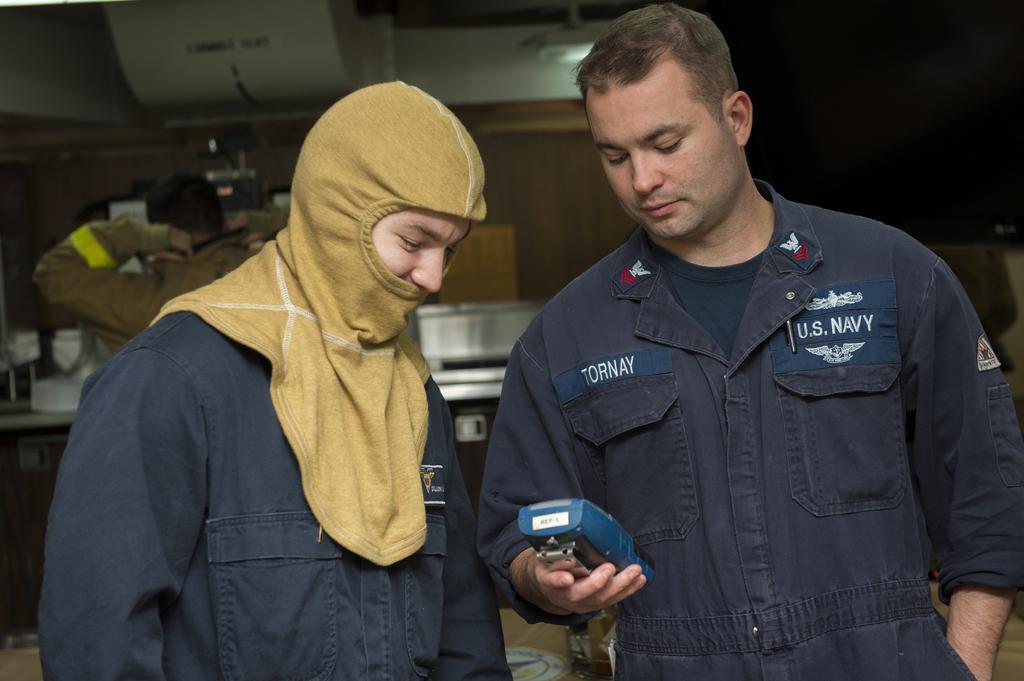Could you give a brief overview of what you see in this image? In this image in the front there are persons standing. On the right side there is a man standing and holding an object which is blue in colour. In the background there is a person and there are objects. 